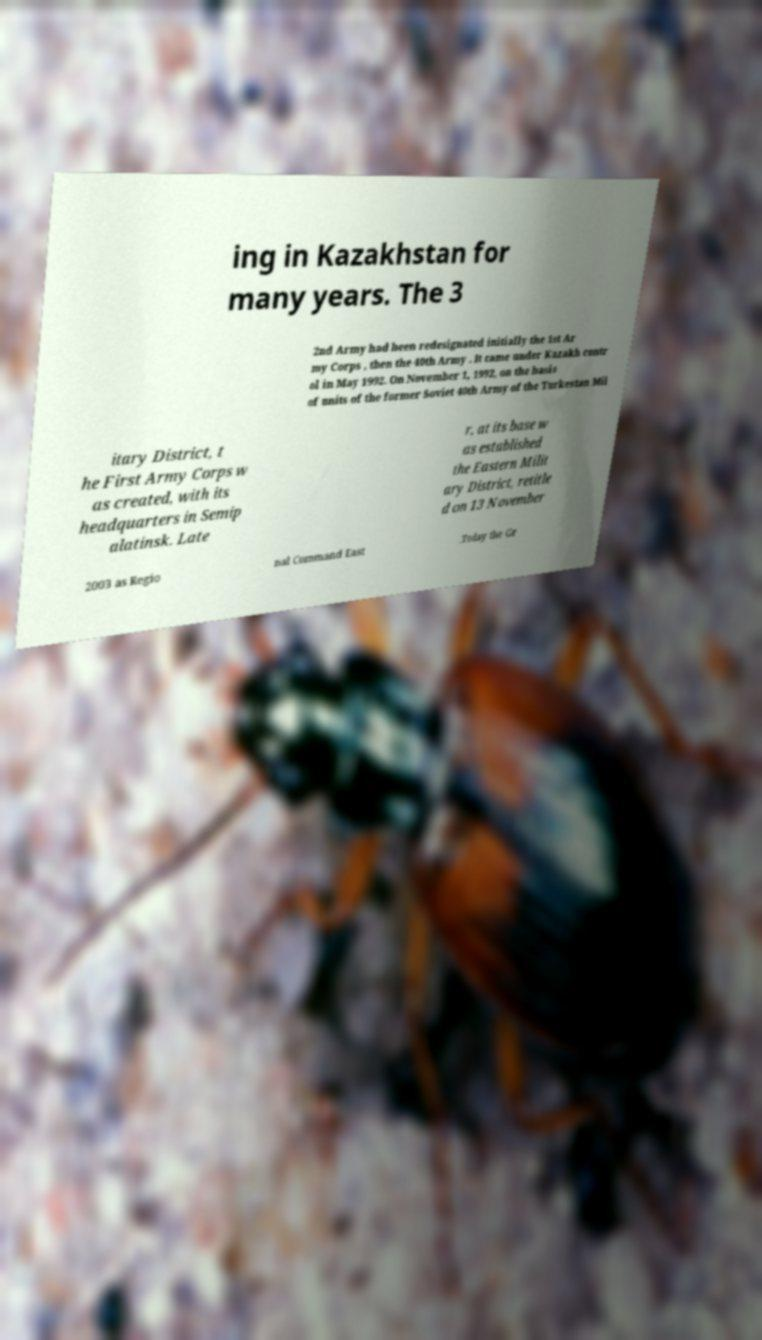There's text embedded in this image that I need extracted. Can you transcribe it verbatim? ing in Kazakhstan for many years. The 3 2nd Army had been redesignated initially the 1st Ar my Corps , then the 40th Army . It came under Kazakh contr ol in May 1992. On November 1, 1992, on the basis of units of the former Soviet 40th Army of the Turkestan Mil itary District, t he First Army Corps w as created, with its headquarters in Semip alatinsk. Late r, at its base w as established the Eastern Milit ary District, retitle d on 13 November 2003 as Regio nal Command East .Today the Gr 